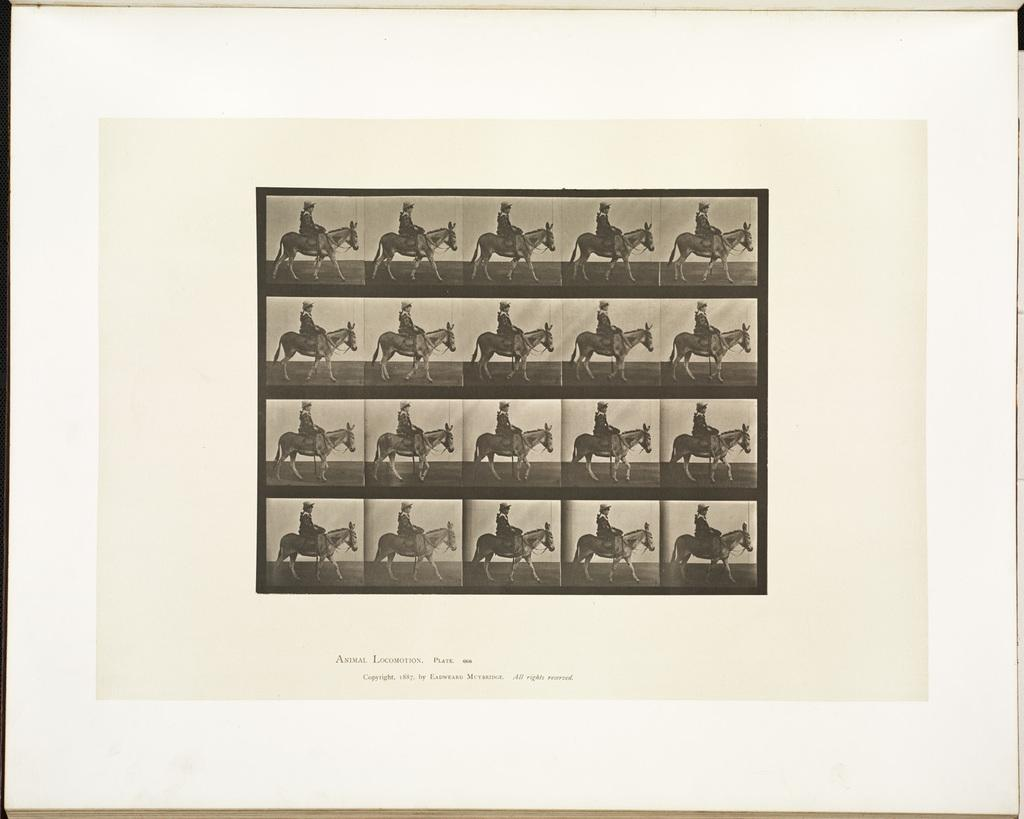What type of visual is the image in question? The image is a poster. What subjects are depicted on the poster? There are multiple images of a person and a horse on the poster. Is there any text present on the poster? Yes, there is text at the bottom of the poster. Can you see any flowers in the river on the poster? There is no river or flowers depicted on the poster; it features multiple images of a person and a horse with text at the bottom. 